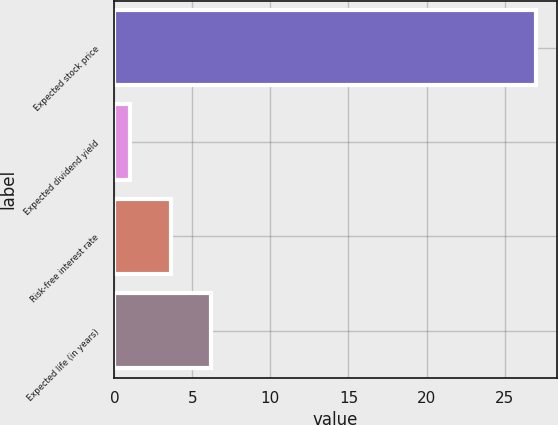Convert chart. <chart><loc_0><loc_0><loc_500><loc_500><bar_chart><fcel>Expected stock price<fcel>Expected dividend yield<fcel>Risk-free interest rate<fcel>Expected life (in years)<nl><fcel>27<fcel>1<fcel>3.6<fcel>6.2<nl></chart> 